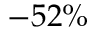<formula> <loc_0><loc_0><loc_500><loc_500>- 5 2 \%</formula> 